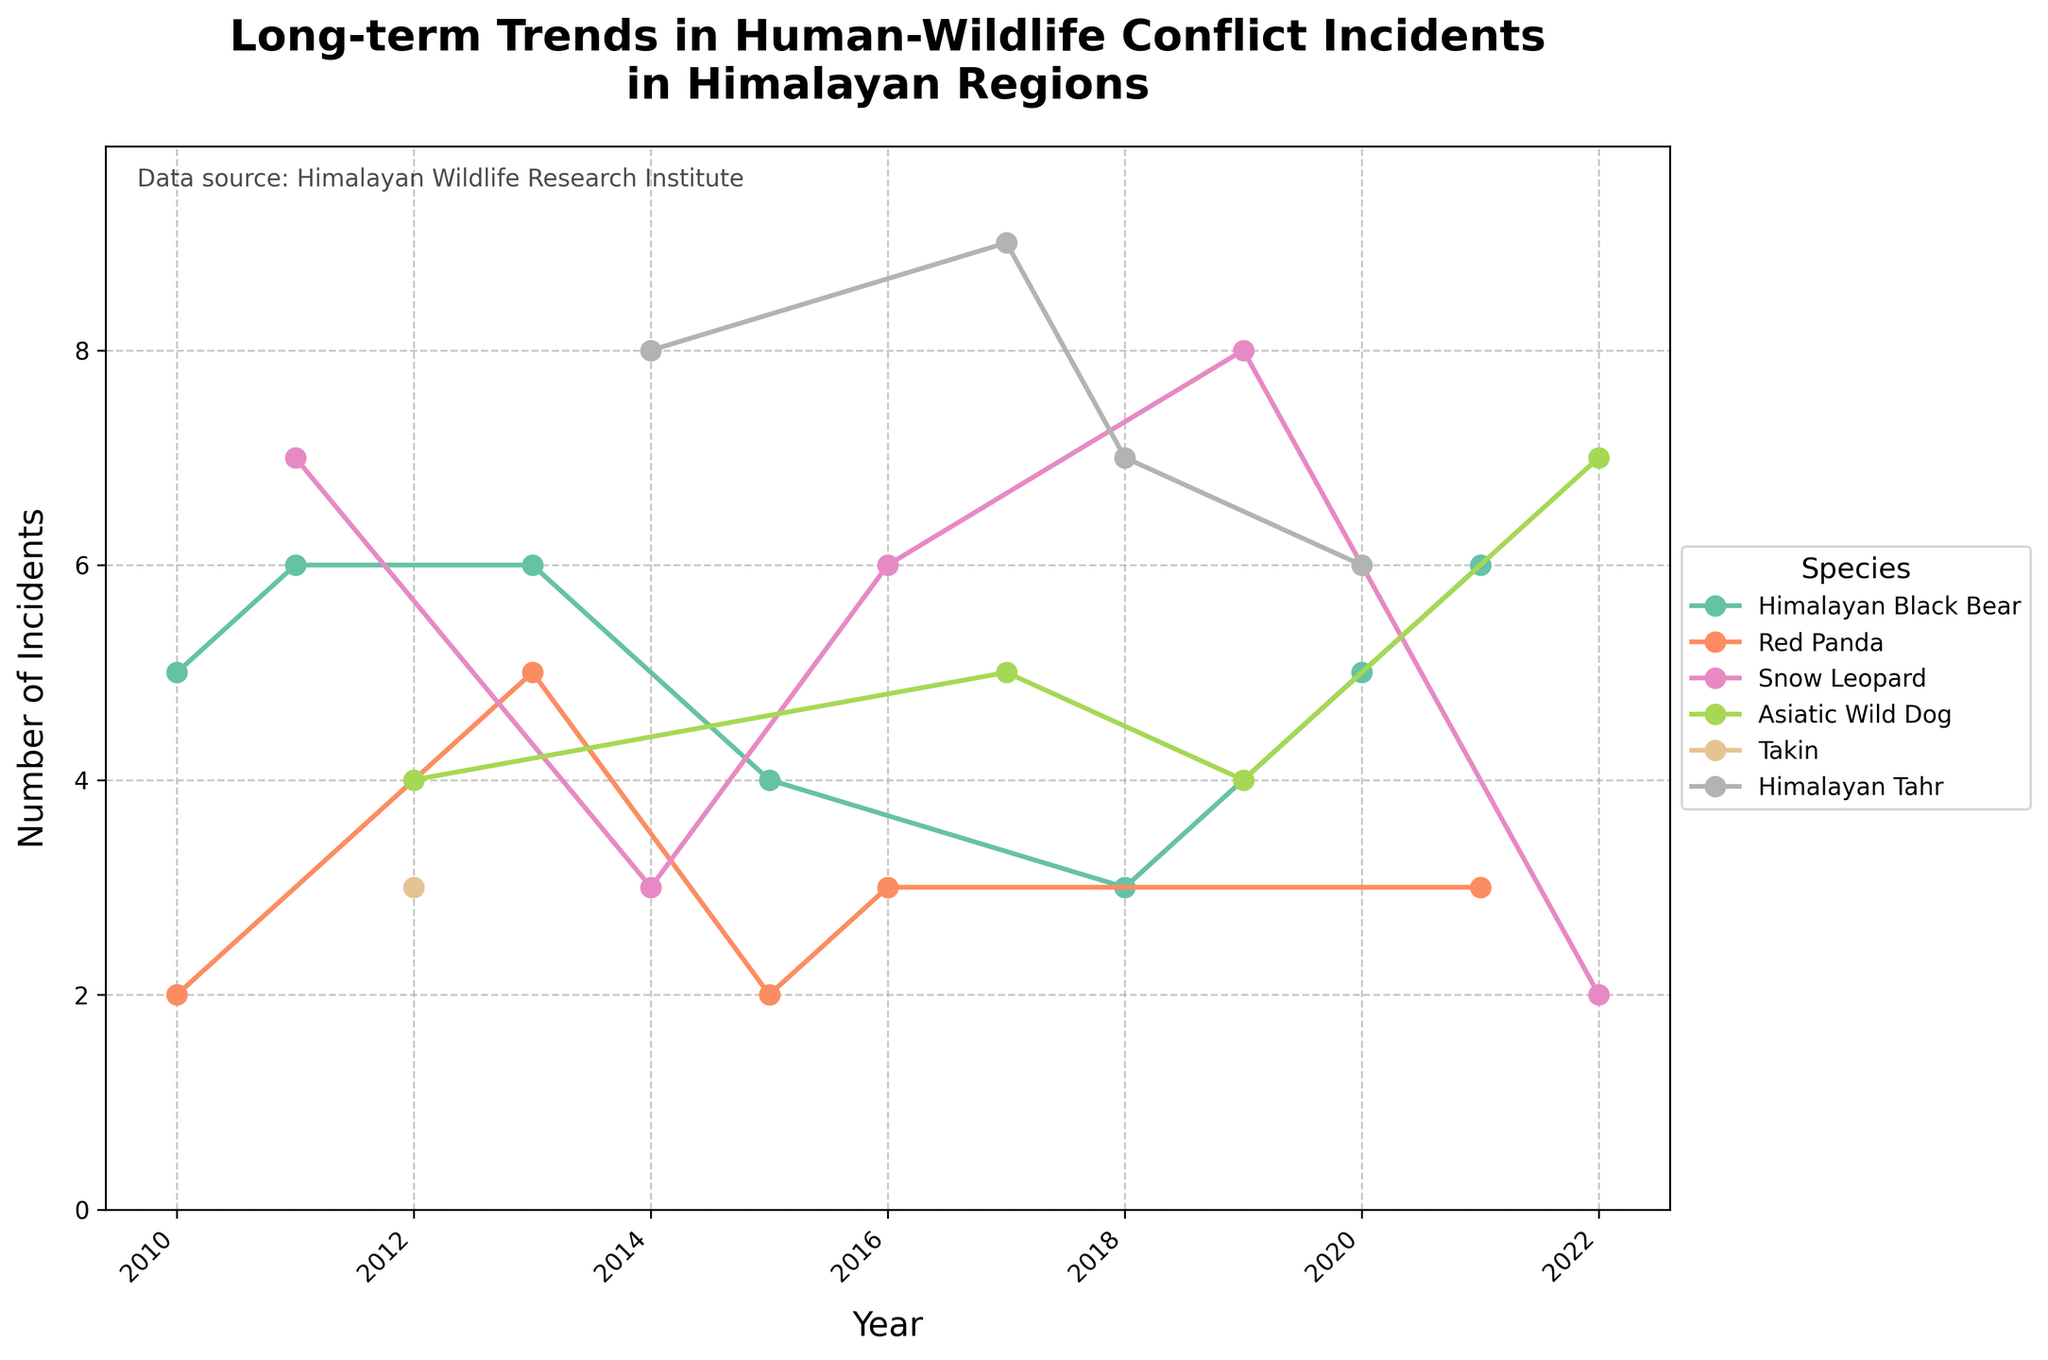What is the title of the plot? The title of the plot is written at the top and reads "Long-term Trends in Human-Wildlife Conflict Incidents in Himalayan Regions"
Answer: Long-term Trends in Human-Wildlife Conflict Incidents in Himalayan Regions What information is displayed on the x-axis? The x-axis is labeled "Year" and shows a timeline ranging from 2010 to 2022, with major ticks every two years.
Answer: Year What is the y-axis label and its range? The y-axis is labeled "Number of Incidents" and ranges from 0 to slightly above 9.
Answer: Number of Incidents, 0-9 Which species has the highest number of incidents in any given year? To answer this, observe the highest peak for each species' line. The Himalayan Tahr in 2017 shows the highest peak with 9 incidents.
Answer: Himalayan Tahr How many incidents involving the Red Panda occurred in 2015 in Ladakh? The Red Panda's data point in 2015 at Ladakh shows 2 incidents.
Answer: 2 Can you list the species that had incidents in both Garhwal and Darjeeling regions? By checking the plot, the species that appear both in Garhwal and Darjeeling are Snow Leopard and Himalayan Tahr.
Answer: Snow Leopard, Himalayan Tahr Which species had fluctuating trends over the years? By looking at the changes in the lines over time, the Himalayan Black Bear shows a fluctuating trend with varying incidents year by year.
Answer: Himalayan Black Bear Which region had the most consistent trend for any species? The Red Panda in Nepal shows a steady trend with multiple instances of the same number of incidents over the years.
Answer: Nepal (Red Panda) How many total incidents occurred for Snow Leopard across all regions and years? Count each data point for Snow Leopard and sum the incidents: 7 (2011) + 3 (2014) + 6 (2016) + 8 (2019) + 2 (2022) = 26.
Answer: 26 Which species had an increasing trend in the number of incidents over the years? The plot shows an apparent increasing trend for the Himalayan Tahr, especially noticeable in later years.
Answer: Himalayan Tahr 